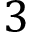Convert formula to latex. <formula><loc_0><loc_0><loc_500><loc_500>3</formula> 